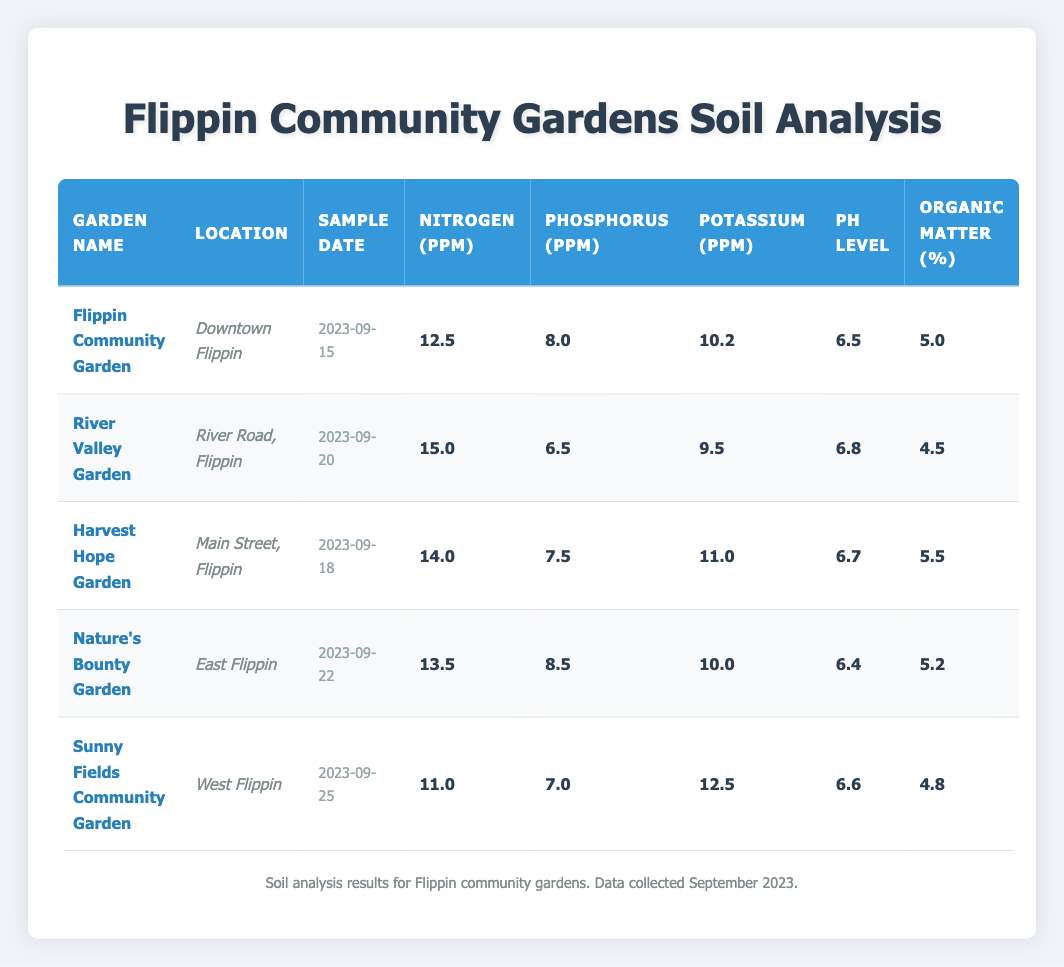What is the nitrogen level in the Flippin Community Garden? The nitrogen level is directly stated in the Flippin Community Garden row of the table. The nitrogen level is 12.5 ppm.
Answer: 12.5 ppm Which garden has the highest potassium level? By examining the potassium levels across all gardens, Sunny Fields Community Garden has the highest potassium level at 12.5 ppm.
Answer: Sunny Fields Community Garden What is the average pH level of all the community gardens? To find the average pH level, sum the pH levels: (6.5 + 6.8 + 6.7 + 6.4 + 6.6) = 32.0. Then divide by the number of gardens (5): 32.0 / 5 = 6.4.
Answer: 6.4 Is the organic matter percentage in River Valley Garden above 5%? The organic matter percentage in River Valley Garden is listed as 4.5%, which confirms that it is below 5%.
Answer: No What is the difference in nitrogen levels between the highest and lowest among these gardens? The highest nitrogen level is 15.0 ppm (River Valley Garden), and the lowest is 11.0 ppm (Sunny Fields Community Garden). The difference is 15.0 - 11.0 = 4.0 ppm.
Answer: 4.0 ppm Which garden has the highest phosphorus level, and what is that level? By comparing the phosphorus levels, Nature's Bounty Garden has the highest phosphorus level at 8.5 ppm.
Answer: Nature's Bounty Garden, 8.5 ppm How many gardens have a pH level greater than 6.5? By checking each garden's pH levels, we find River Valley Garden (6.8), Harvest Hope Garden (6.7), and Sunny Fields Community Garden (6.6) have pH levels greater than 6.5. This totals 3 gardens.
Answer: 3 gardens What is the nitrogen level of Harvest Hope Garden and how does it compare to Nature's Bounty Garden? Harvest Hope Garden has a nitrogen level of 14.0 ppm, while Nature's Bounty Garden has 13.5 ppm. The difference is that Harvest Hope Garden has 0.5 ppm more nitrogen than Nature's Bounty Garden.
Answer: Harvest Hope Garden, 0.5 ppm more Do all community gardens have a potassium level above 8 ppm? By comparing the potassium levels in the table, Sunny Fields Community Garden's potassium level is 12.5 ppm, which is above 8 ppm, while River Valley Garden has 9.5 ppm, which is also above 8 ppm. All gardens listed have potassium levels above 8 ppm.
Answer: Yes 